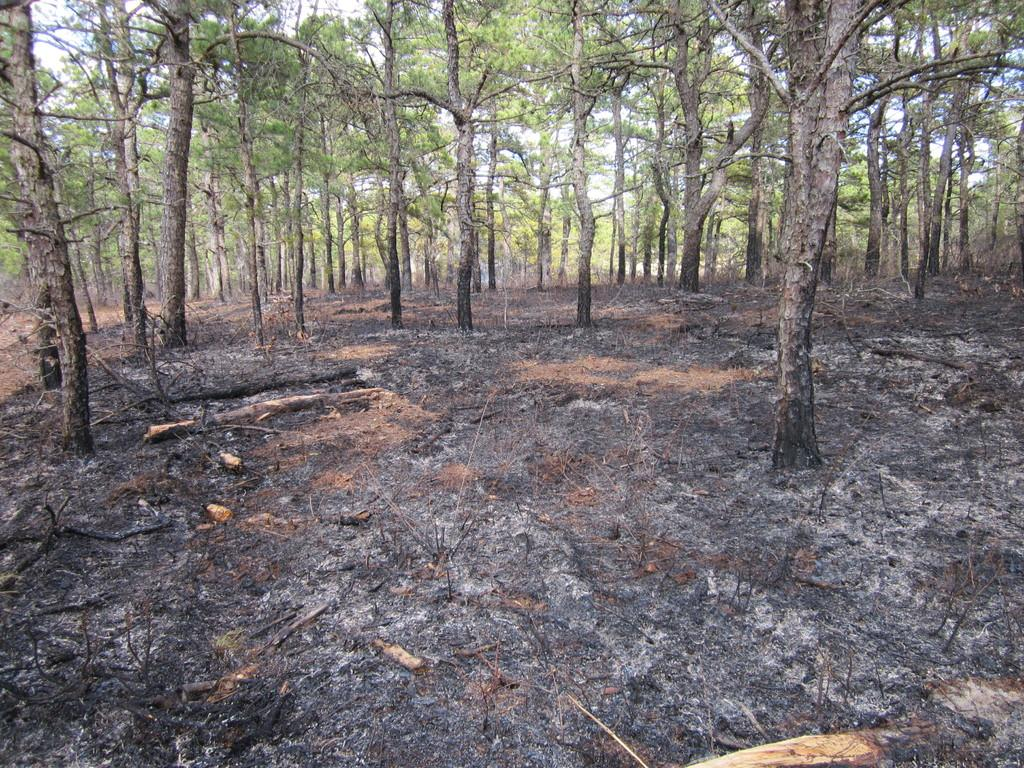What type of vegetation is present in the image? There are many trees in the image. What is the condition of the sky in the image? The sky is clear in the image. What type of doll can be seen interacting with the beast in the image? There is no doll or beast present in the image; it only features trees and a clear sky. 